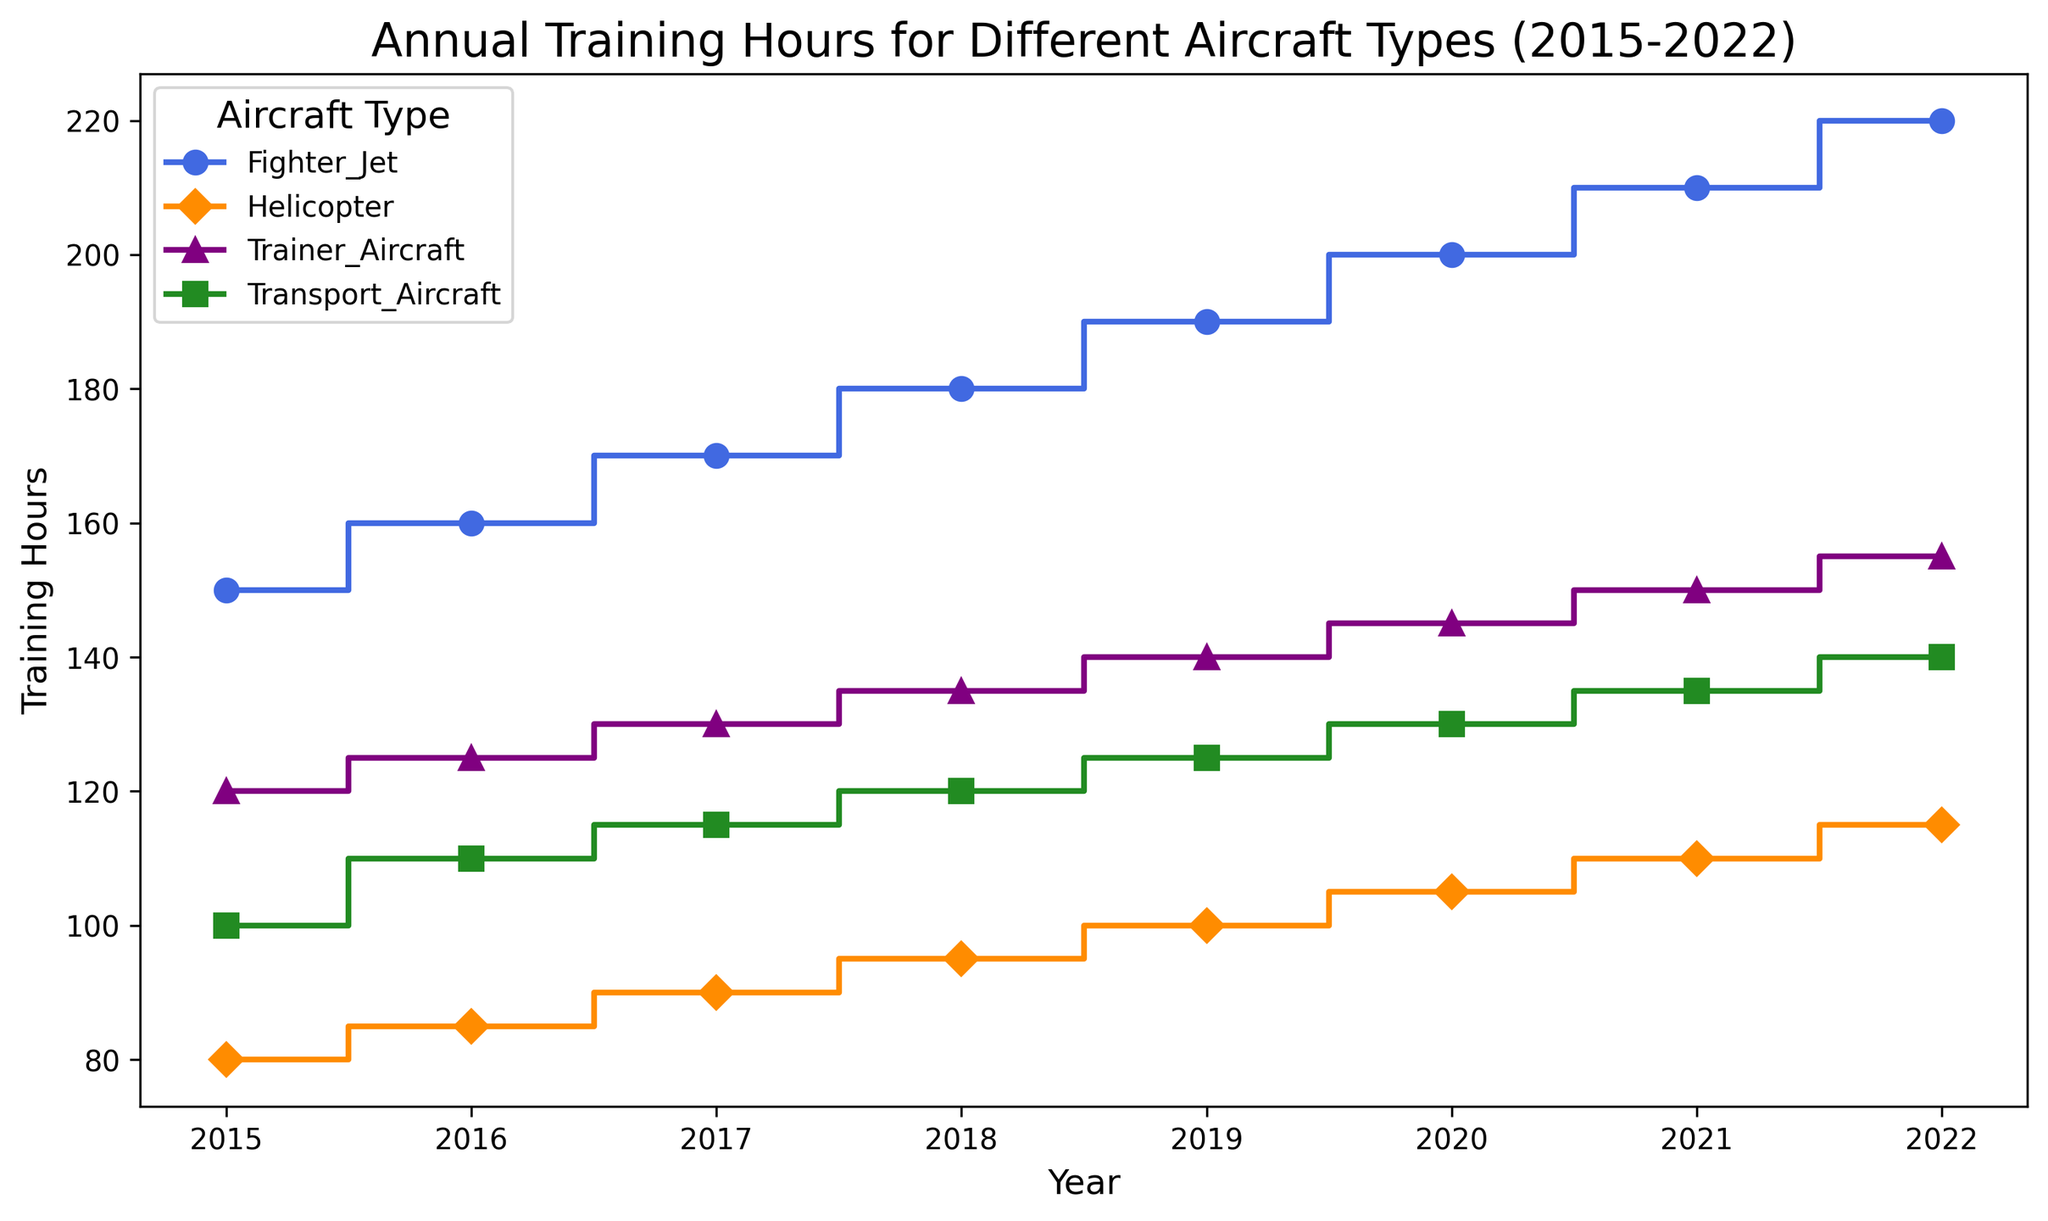What is the trend of training hours for Fighter Jets from 2015 to 2022? Looking at the step plot, the training hours for Fighter Jets have consistently increased each year from 2015 to 2022.
Answer: Increasing trend Which aircraft type had the highest training hours in 2020? In 2020, the Fighter Jets had the highest training hours, reaching 200 hours.
Answer: Fighter Jet By how much did the training hours for Helicopters increase from 2015 to 2022? The training hours for Helicopters in 2015 were 80, and in 2022 they were 115. The increase is 115 - 80 = 35 hours.
Answer: 35 hours Which aircraft type had the smallest increase in training hours from 2015 to 2022? Comparing the increases:
- Fighter Jet: 220 - 150 = 70 hours
- Transport Aircraft: 140 - 100 = 40 hours
- Helicopter: 115 - 80 = 35 hours
- Trainer Aircraft: 155 - 120 = 35 hours
Both Helicopters and Trainer Aircraft had the smallest increase of 35 hours.
Answer: Helicopter and Trainer Aircraft In 2018, which aircraft type had the third highest training hours? In 2018, the training hours were:
- Fighter Jet: 180
- Transport Aircraft: 120
- Helicopter: 95
- Trainer Aircraft: 135
The third highest is the Transport Aircraft with 120 hours.
Answer: Transport Aircraft How do the trends in training hours for Fighter Jets and Transport Aircraft compare from 2015 to 2022? Both Fighter Jets and Transport Aircraft show an increasing trend from 2015 to 2022. However, the rate of increase for Fighter Jets is steeper than that for Transport Aircraft.
Answer: Both increasing, Fighter Jets steeper Which year saw the highest total training hours across all aircraft types? Summing the training hours for each year:
- 2015: 150 + 100 + 80 + 120 = 450
- 2016: 160 + 110 + 85 + 125 = 480
- 2017: 170 + 115 + 90 + 130 = 505
- 2018: 180 + 120 + 95 + 135 = 530
- 2019: 190 + 125 + 100 + 140 = 555
- 2020: 200 + 130 + 105 + 145 = 580
- 2021: 210 + 135 + 110 + 150 = 605
- 2022: 220 + 140 + 115 + 155 = 630
The year with the highest total training hours is 2022, with 630 hours.
Answer: 2022 How do training hours for Trainer Aircraft in 2020 compare to those for Helicopters in 2021? Training hours for Trainer Aircraft in 2020 are 145, while for Helicopters in 2021 they are 110. Trainer Aircraft have more training hours.
Answer: Trainer Aircraft have more What is the average annual increase in training hours for Transport Aircraft from 2015 to 2022? The total increase in training hours for Transport Aircraft from 2015 (100 hours) to 2022 (140 hours) is 40 hours over 7 years. The average annual increase is 40 / 7 ≈ 5.71 hours.
Answer: Approximately 5.71 hours 